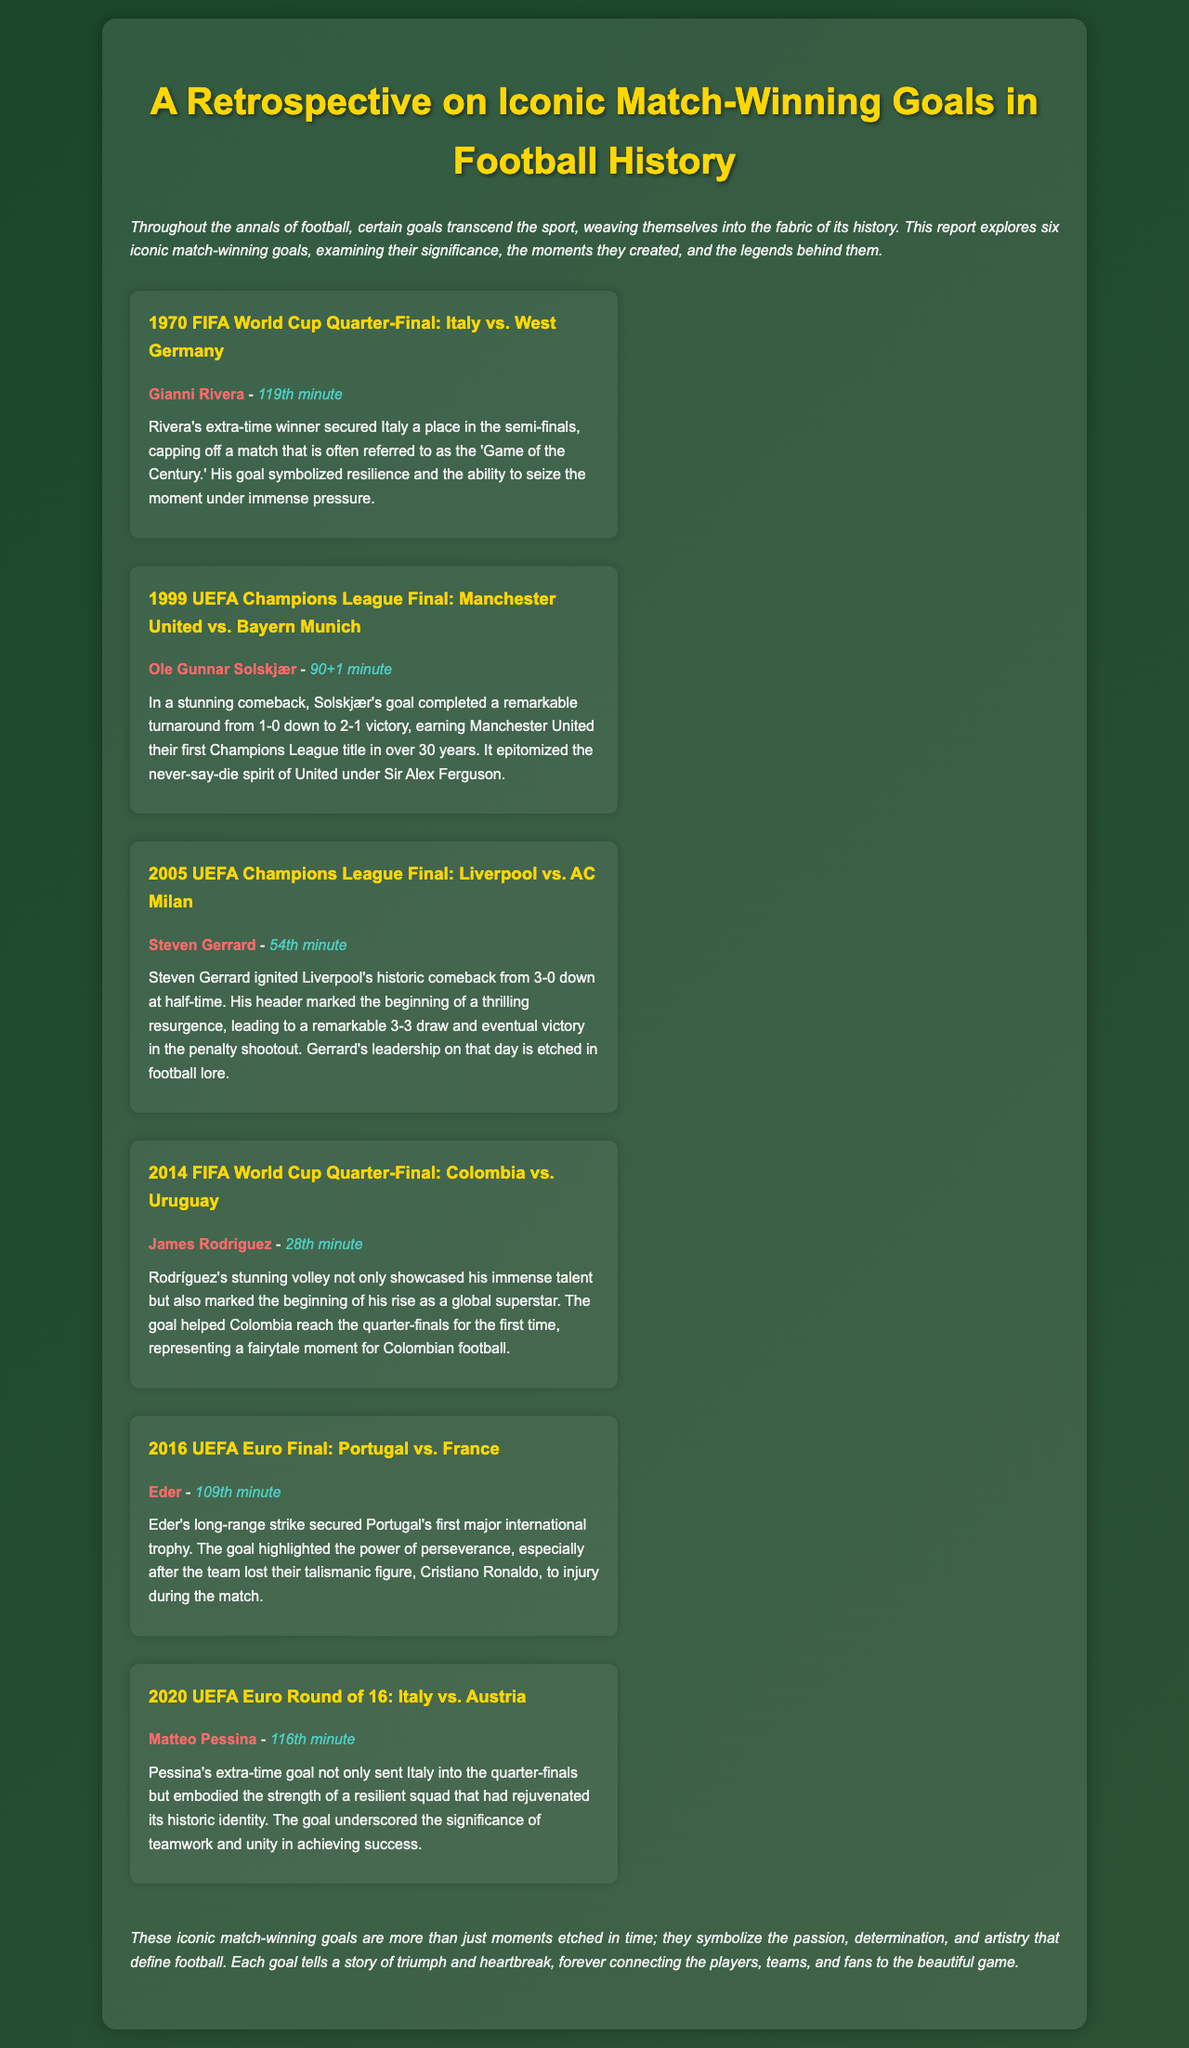what was the year of the Italy vs. West Germany match? The match took place in the 1970 FIFA World Cup Quarter-Final, which is in the year 1970.
Answer: 1970 who scored the winning goal for Manchester United in 1999? The winning goal for Manchester United was scored by Ole Gunnar Solskjær.
Answer: Ole Gunnar Solskjær how many goals did Steven Gerrard score in the 2005 UEFA Champions League Final? The document refers to Gerrard's goal marking the beginning of a comeback, indicating he scored one goal in the final.
Answer: One what minute did Eder score in the Euro Final? Eder scored in the 109th minute of the match against France during the 2016 UEFA Euro Final.
Answer: 109th minute which player's goal helped Colombia reach the quarter-finals for the first time? The goal that helped Colombia reach the quarter-finals was scored by James Rodríguez.
Answer: James Rodríguez what is the significance of Matteo Pessina's goal in the 2020 UEFA Euro? Pessina's goal embodies the strength of a resilient squad and sent Italy into the quarter-finals.
Answer: Resilience and teamwork what was the nickname given to the match between Italy and West Germany in 1970? The match is often referred to as the 'Game of the Century.'
Answer: Game of the Century how many iconic match-winning goals are discussed in the document? The report explores six iconic match-winning goals in total.
Answer: Six what was the outcome of the 2005 UEFA Champions League Final? The outcome was a remarkable 3-3 draw leading to Liverpool's victory in the penalty shootout.
Answer: Penalty shootout victory 